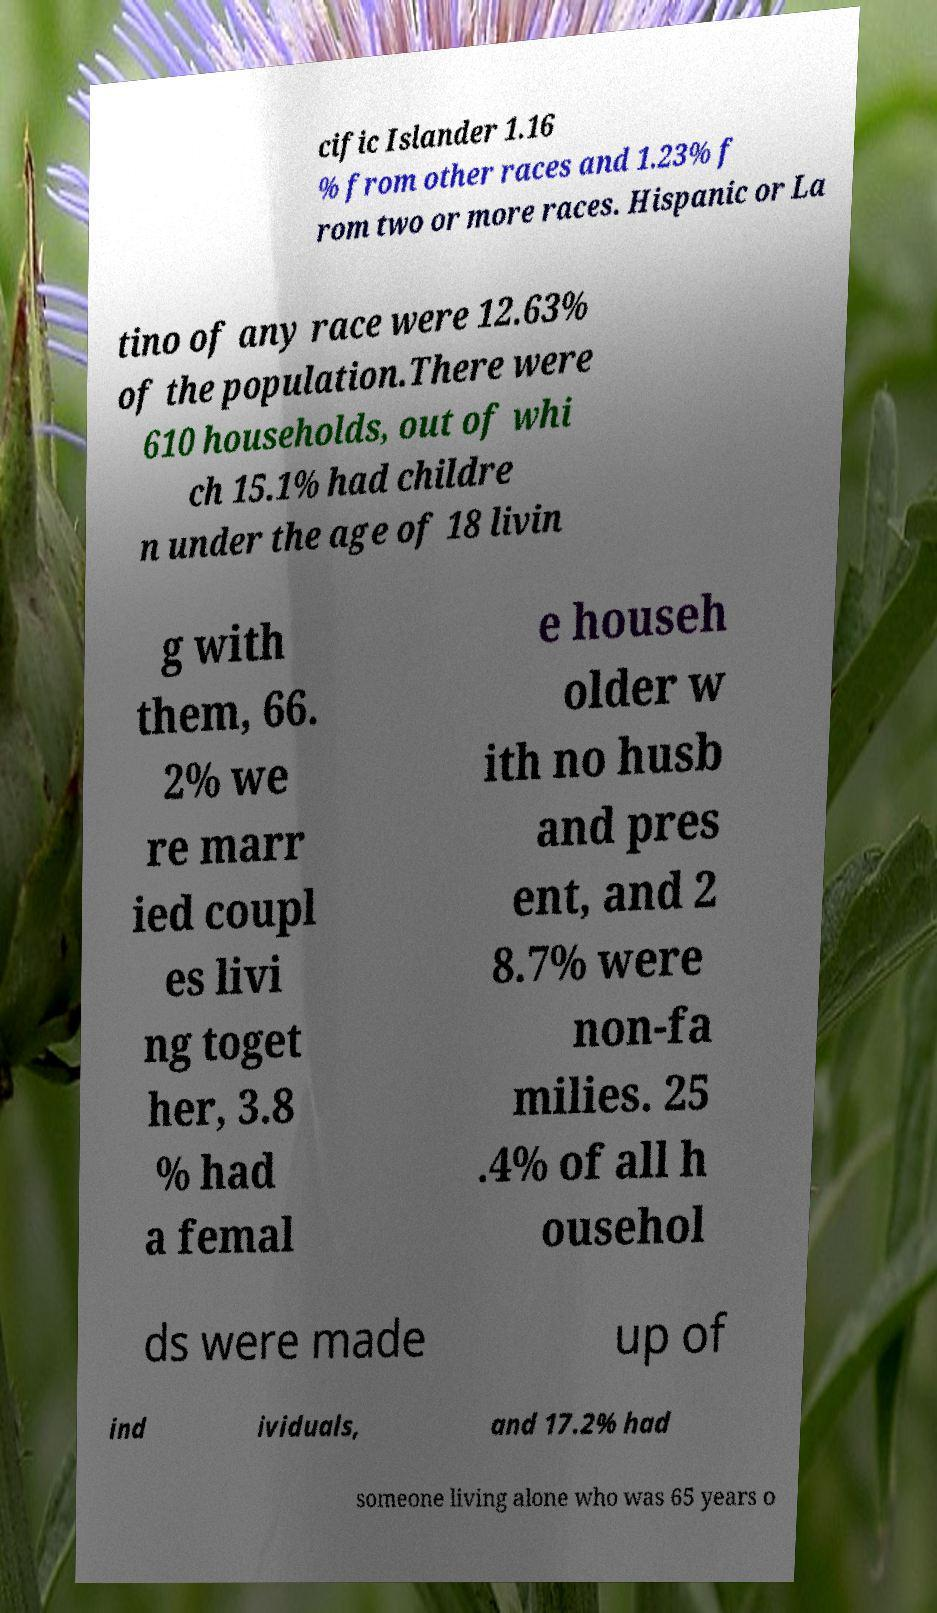Could you assist in decoding the text presented in this image and type it out clearly? cific Islander 1.16 % from other races and 1.23% f rom two or more races. Hispanic or La tino of any race were 12.63% of the population.There were 610 households, out of whi ch 15.1% had childre n under the age of 18 livin g with them, 66. 2% we re marr ied coupl es livi ng toget her, 3.8 % had a femal e househ older w ith no husb and pres ent, and 2 8.7% were non-fa milies. 25 .4% of all h ousehol ds were made up of ind ividuals, and 17.2% had someone living alone who was 65 years o 